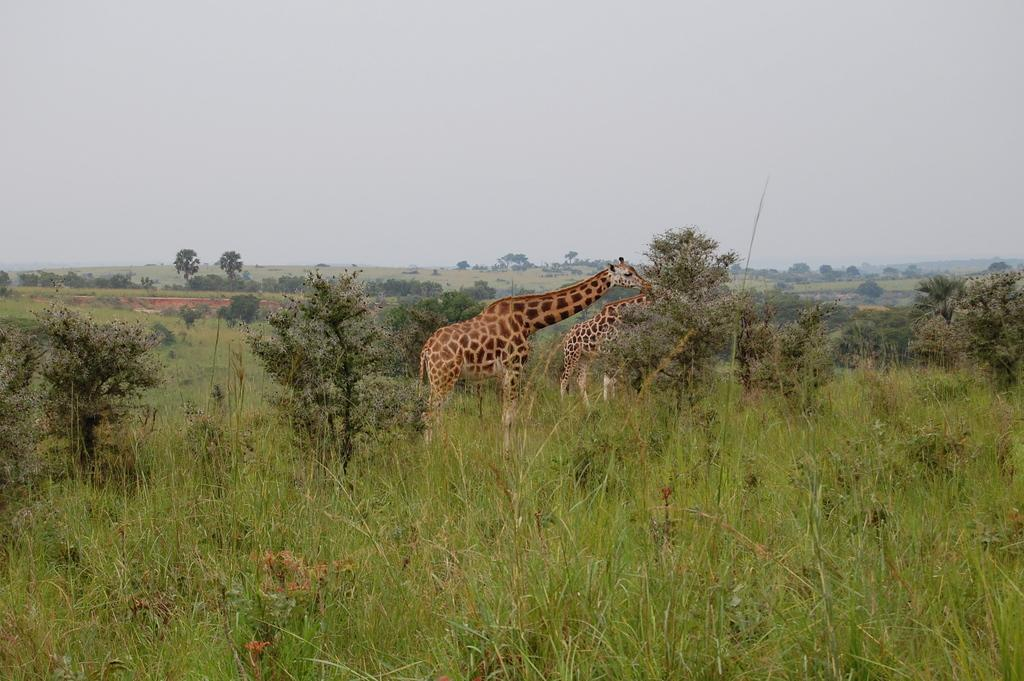What is the setting of the image? The image is an outside view. What animals can be seen in the image? There are two giraffes in the middle of the image. What type of vegetation is present in the image? There are many trees in the image. What is visible at the bottom of the image? Grass is visible at the bottom of the image. What is visible at the top of the image? The sky is visible at the top of the image. What type of rail can be seen in the image? There is no rail present in the image; it features an outside view with two giraffes, trees, grass, and the sky. How many roses are visible in the image? There are no roses present in the image; it features an outside view with two giraffes, trees, grass, and the sky. 